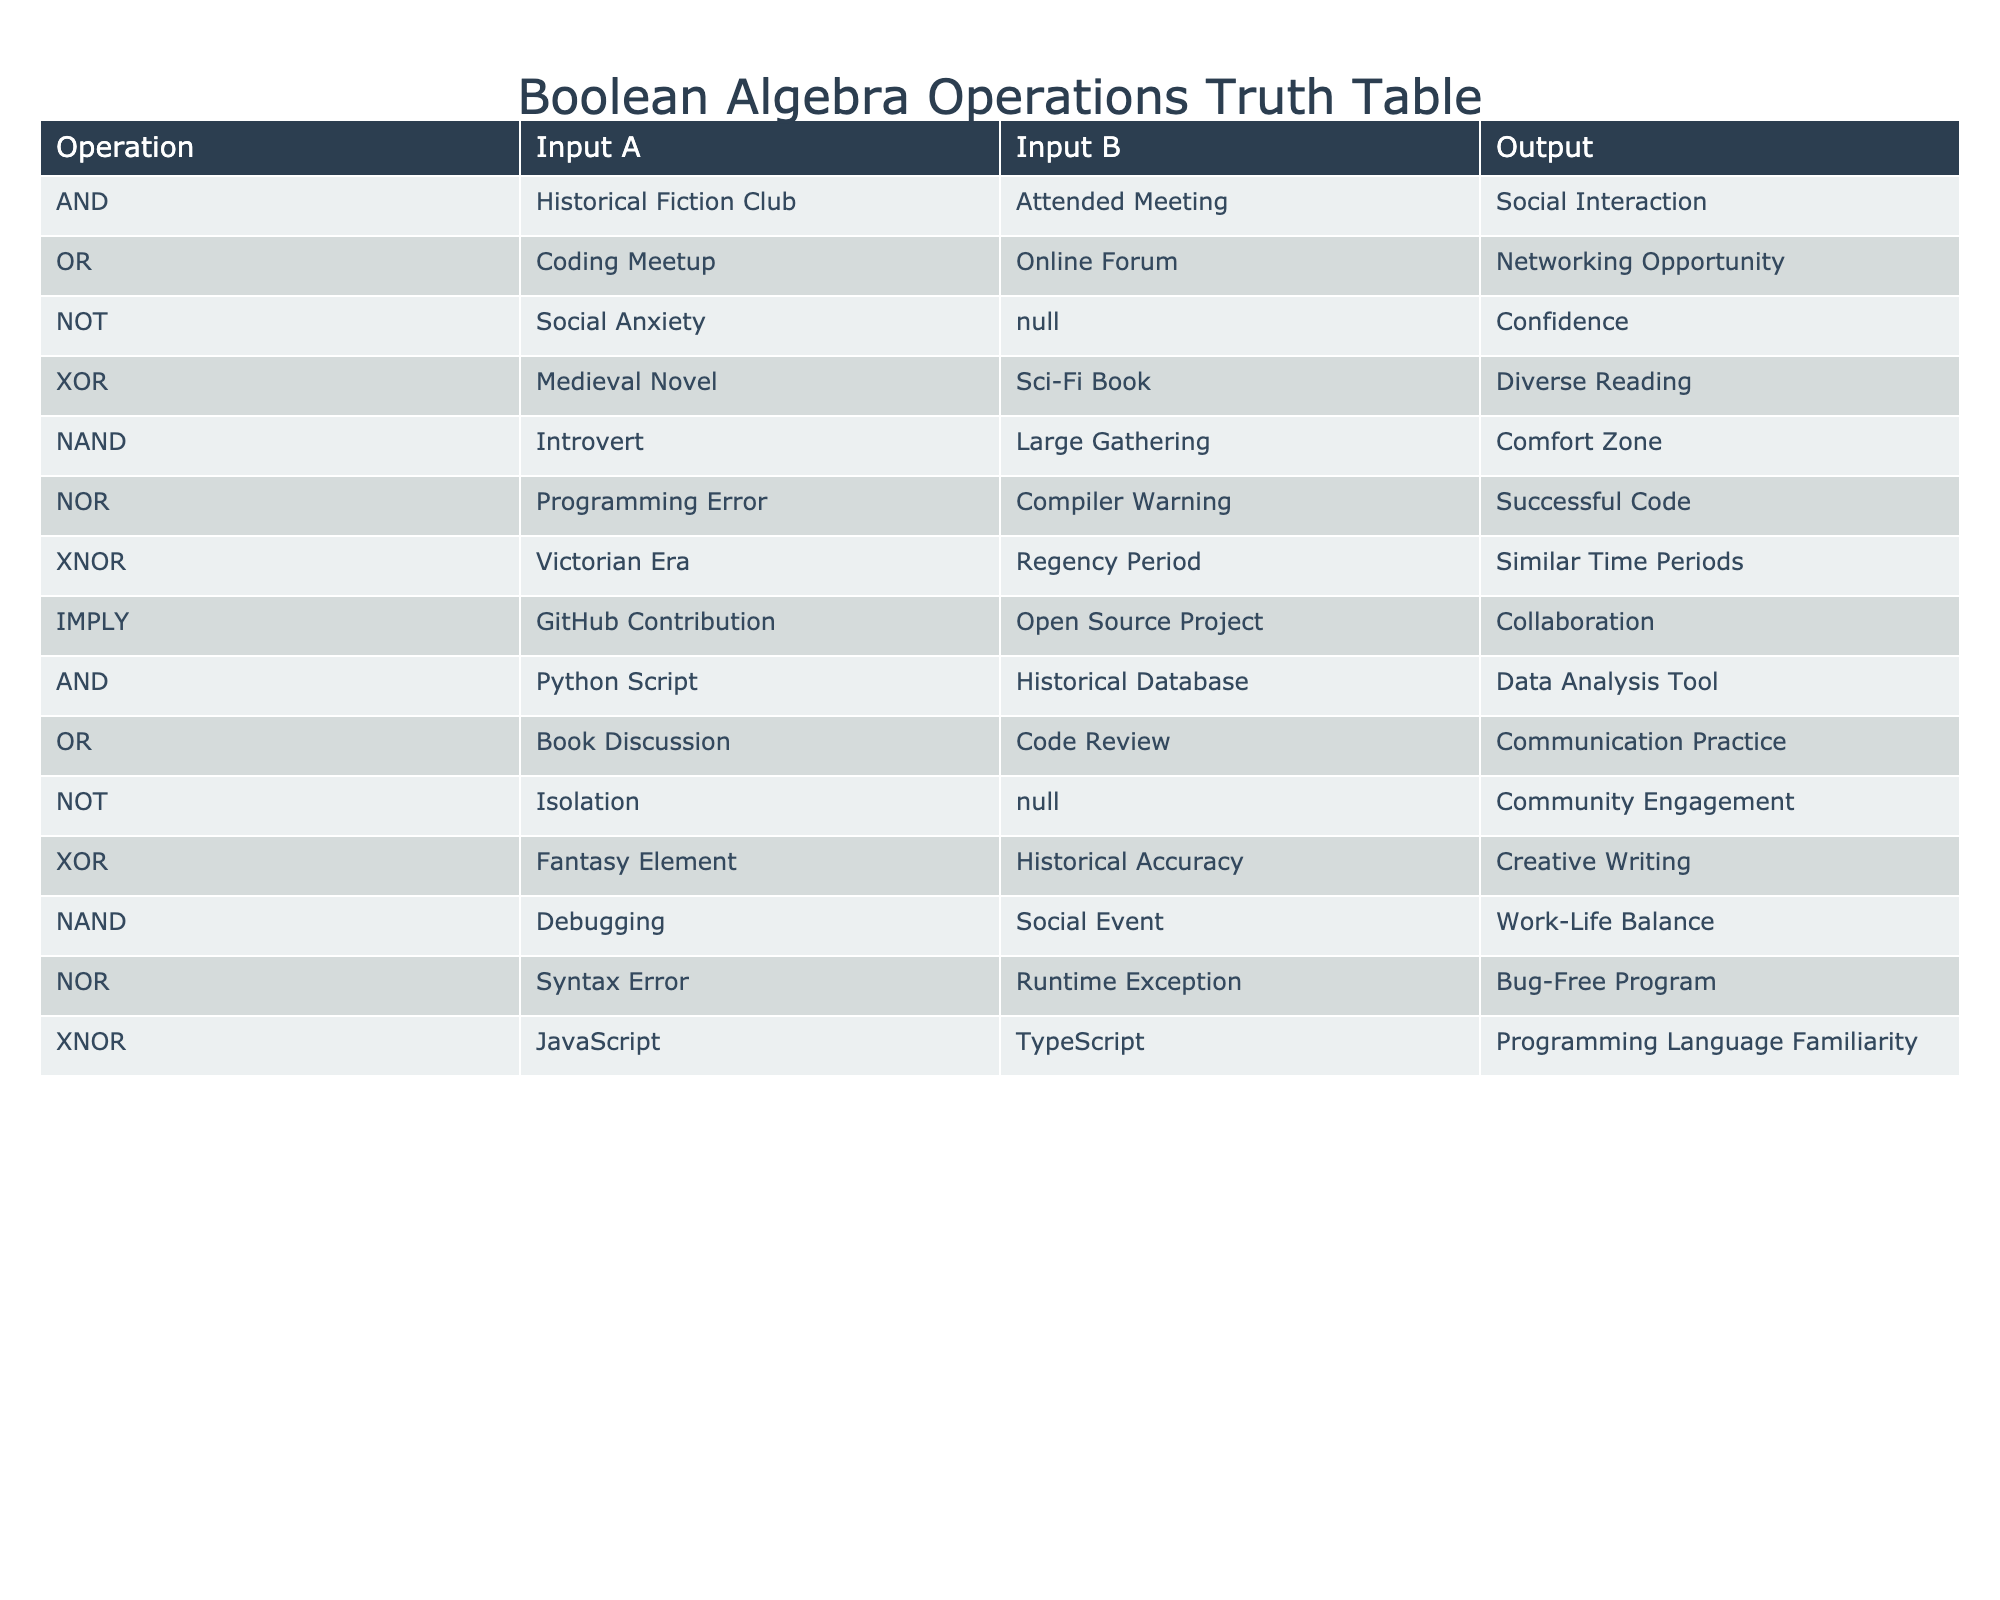What is the output of the AND operation for the Historical Fiction Club and Attended Meeting? According to the table, the output for the AND operation with inputs "Historical Fiction Club" and "Attended Meeting" is "Social Interaction."
Answer: Social Interaction What is the output of the OR operation combining Coding Meetup and Online Forum? In the table, the output for the OR operation with inputs "Coding Meetup" and "Online Forum" is "Networking Opportunity."
Answer: Networking Opportunity Is the output of the NOT operation for Social Anxiety equal to Community Engagement? The output of the NOT operation for "Social Anxiety" is "Confidence," which is not equal to "Community Engagement." Therefore, the answer is false.
Answer: No What is the relationship between the input of the XOR operation Medival Novel and the output of Diverse Reading? The XOR operation compares two unique inputs or states. Here, pairing the "Medieval Novel" with "Sci-Fi Book" results in the output "Diverse Reading," indicating these two genres provide differing experiences.
Answer: Diverse Reading What would be the output if we applied NAND on Debugging and Social Event? The NAND operation yields "Work-Life Balance" when applied to the inputs "Debugging" and "Social Event," which suggests that not attending debugging during a social event may balance work and leisure effectively.
Answer: Work-Life Balance What is the output of the NOR function when applied to the inputs of Syntax Error and Runtime Exception? In the table, the NOR operation with the inputs "Syntax Error" and "Runtime Exception" results in "Bug-Free Program," indicating that if neither error occurs, the output signifies successful coding.
Answer: Bug-Free Program Between the inputs for XNOR, which two inputs yield the output of Similar Time Periods? The XNOR operation for "Victorian Era" and "Regency Period" results in "Similar Time Periods," confirming both inputs share qualities that place them in similar historical contexts.
Answer: Similar Time Periods Is there a social opportunity outcome related to the NOT operation when the input is Isolation? The table states that the NOT operation with input "Isolation" results in "Community Engagement," demonstrating that turning away from isolation leads to social opportunities.
Answer: Yes What is the different interaction outcome derived from comparing the AND operation with Python Script and Historical Database? The AND operation joins the inputs "Python Script" and "Historical Database," resulting in the output "Data Analysis Tool," indicating the combined benefit of the two inputs leads to a useful tool in research.
Answer: Data Analysis Tool 